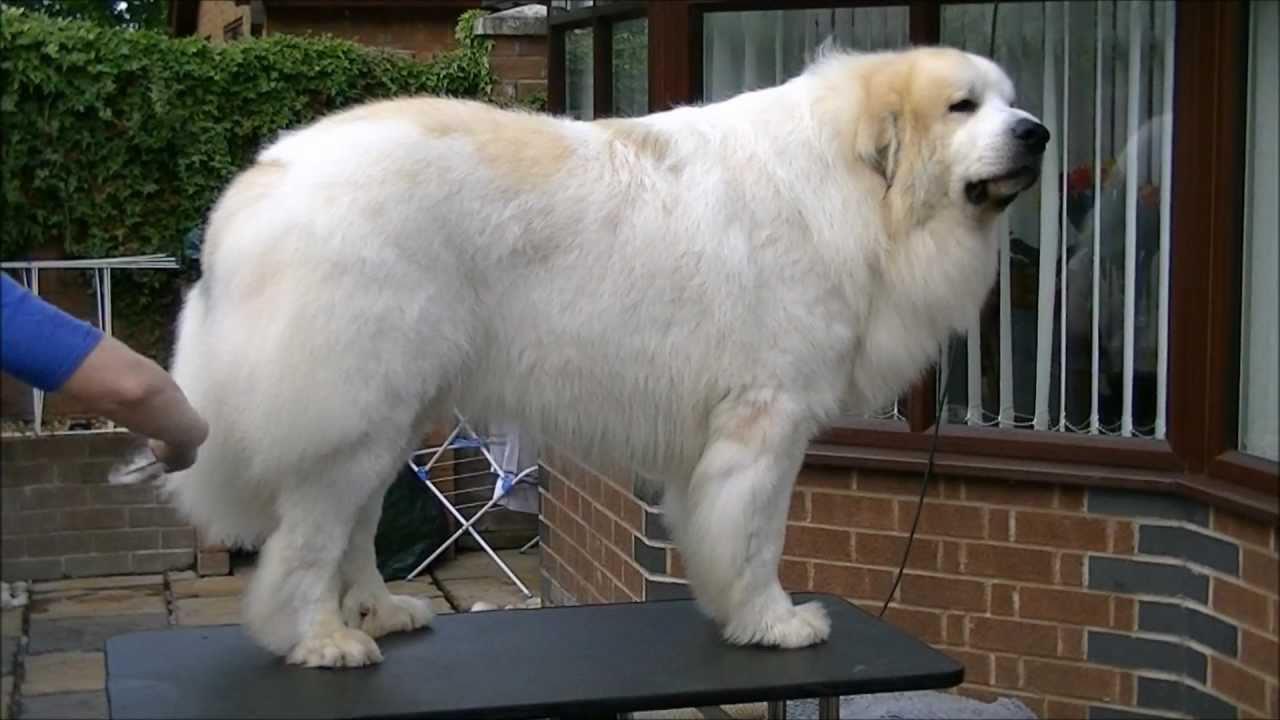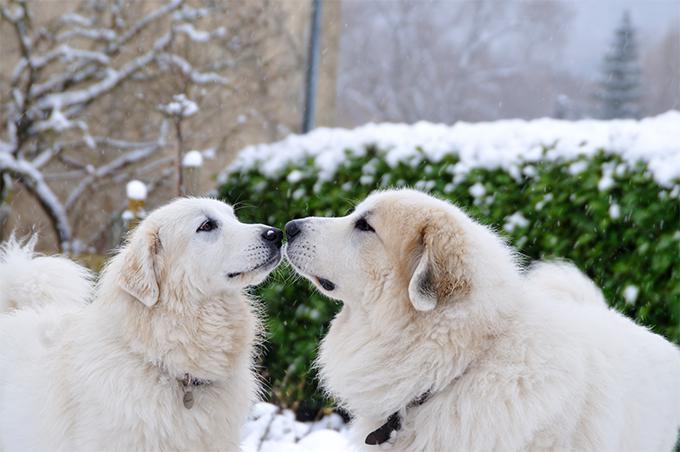The first image is the image on the left, the second image is the image on the right. Evaluate the accuracy of this statement regarding the images: "One of the dogs has its tongue visible.". Is it true? Answer yes or no. No. 